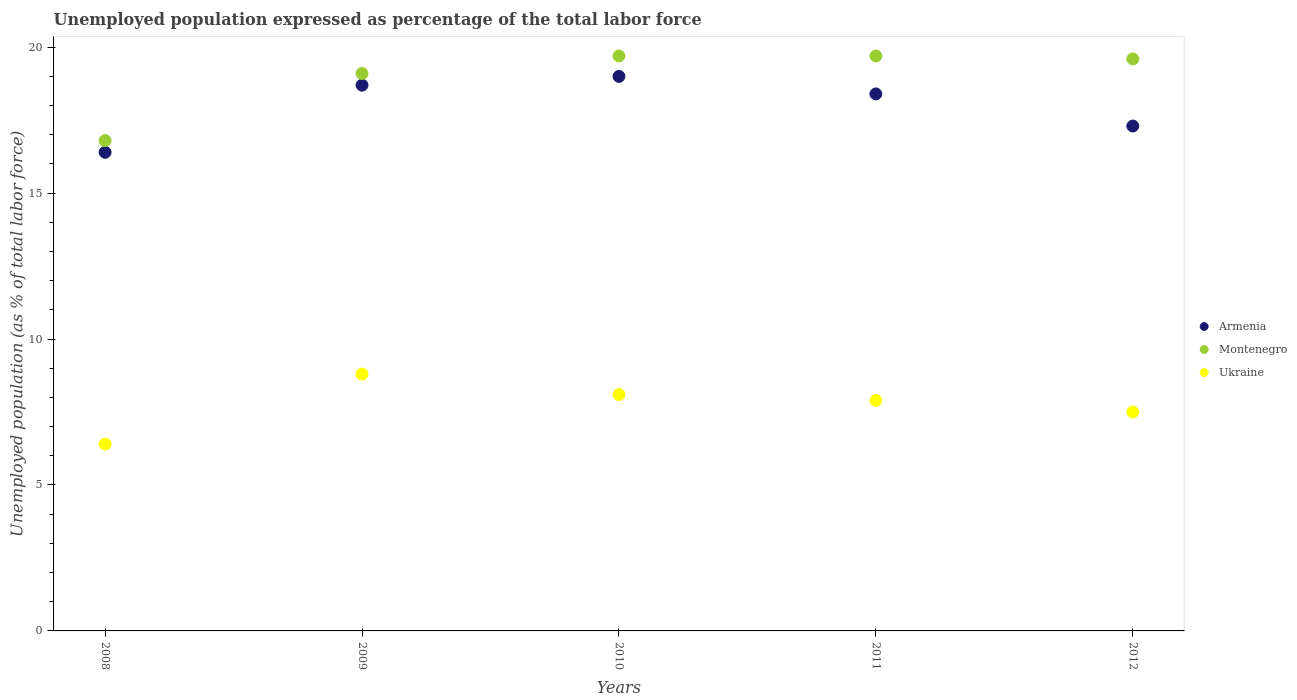Is the number of dotlines equal to the number of legend labels?
Give a very brief answer. Yes. What is the unemployment in in Montenegro in 2010?
Give a very brief answer. 19.7. Across all years, what is the minimum unemployment in in Armenia?
Ensure brevity in your answer.  16.4. What is the total unemployment in in Ukraine in the graph?
Keep it short and to the point. 38.7. What is the difference between the unemployment in in Ukraine in 2009 and that in 2011?
Make the answer very short. 0.9. What is the difference between the unemployment in in Ukraine in 2011 and the unemployment in in Armenia in 2012?
Offer a very short reply. -9.4. What is the average unemployment in in Ukraine per year?
Your answer should be compact. 7.74. In the year 2011, what is the difference between the unemployment in in Armenia and unemployment in in Montenegro?
Ensure brevity in your answer.  -1.3. What is the ratio of the unemployment in in Armenia in 2011 to that in 2012?
Your answer should be compact. 1.06. What is the difference between the highest and the second highest unemployment in in Montenegro?
Offer a very short reply. 0. What is the difference between the highest and the lowest unemployment in in Armenia?
Your answer should be compact. 2.6. Is the sum of the unemployment in in Montenegro in 2009 and 2011 greater than the maximum unemployment in in Armenia across all years?
Keep it short and to the point. Yes. Is it the case that in every year, the sum of the unemployment in in Ukraine and unemployment in in Armenia  is greater than the unemployment in in Montenegro?
Your response must be concise. Yes. Is the unemployment in in Montenegro strictly greater than the unemployment in in Ukraine over the years?
Provide a short and direct response. Yes. Is the unemployment in in Armenia strictly less than the unemployment in in Montenegro over the years?
Your answer should be compact. Yes. How many dotlines are there?
Give a very brief answer. 3. How many years are there in the graph?
Your response must be concise. 5. How are the legend labels stacked?
Your response must be concise. Vertical. What is the title of the graph?
Keep it short and to the point. Unemployed population expressed as percentage of the total labor force. What is the label or title of the Y-axis?
Ensure brevity in your answer.  Unemployed population (as % of total labor force). What is the Unemployed population (as % of total labor force) in Armenia in 2008?
Give a very brief answer. 16.4. What is the Unemployed population (as % of total labor force) in Montenegro in 2008?
Make the answer very short. 16.8. What is the Unemployed population (as % of total labor force) in Ukraine in 2008?
Keep it short and to the point. 6.4. What is the Unemployed population (as % of total labor force) in Armenia in 2009?
Your answer should be very brief. 18.7. What is the Unemployed population (as % of total labor force) in Montenegro in 2009?
Your answer should be very brief. 19.1. What is the Unemployed population (as % of total labor force) in Ukraine in 2009?
Provide a succinct answer. 8.8. What is the Unemployed population (as % of total labor force) in Montenegro in 2010?
Provide a succinct answer. 19.7. What is the Unemployed population (as % of total labor force) in Ukraine in 2010?
Ensure brevity in your answer.  8.1. What is the Unemployed population (as % of total labor force) of Armenia in 2011?
Give a very brief answer. 18.4. What is the Unemployed population (as % of total labor force) of Montenegro in 2011?
Offer a very short reply. 19.7. What is the Unemployed population (as % of total labor force) of Ukraine in 2011?
Your answer should be compact. 7.9. What is the Unemployed population (as % of total labor force) of Armenia in 2012?
Provide a short and direct response. 17.3. What is the Unemployed population (as % of total labor force) in Montenegro in 2012?
Give a very brief answer. 19.6. Across all years, what is the maximum Unemployed population (as % of total labor force) in Montenegro?
Provide a short and direct response. 19.7. Across all years, what is the maximum Unemployed population (as % of total labor force) in Ukraine?
Your answer should be compact. 8.8. Across all years, what is the minimum Unemployed population (as % of total labor force) in Armenia?
Offer a very short reply. 16.4. Across all years, what is the minimum Unemployed population (as % of total labor force) of Montenegro?
Provide a succinct answer. 16.8. Across all years, what is the minimum Unemployed population (as % of total labor force) of Ukraine?
Ensure brevity in your answer.  6.4. What is the total Unemployed population (as % of total labor force) in Armenia in the graph?
Make the answer very short. 89.8. What is the total Unemployed population (as % of total labor force) in Montenegro in the graph?
Make the answer very short. 94.9. What is the total Unemployed population (as % of total labor force) of Ukraine in the graph?
Your answer should be compact. 38.7. What is the difference between the Unemployed population (as % of total labor force) in Armenia in 2008 and that in 2009?
Give a very brief answer. -2.3. What is the difference between the Unemployed population (as % of total labor force) in Ukraine in 2008 and that in 2009?
Your answer should be very brief. -2.4. What is the difference between the Unemployed population (as % of total labor force) of Armenia in 2008 and that in 2010?
Ensure brevity in your answer.  -2.6. What is the difference between the Unemployed population (as % of total labor force) in Montenegro in 2008 and that in 2010?
Provide a succinct answer. -2.9. What is the difference between the Unemployed population (as % of total labor force) in Ukraine in 2008 and that in 2010?
Provide a short and direct response. -1.7. What is the difference between the Unemployed population (as % of total labor force) of Ukraine in 2008 and that in 2011?
Give a very brief answer. -1.5. What is the difference between the Unemployed population (as % of total labor force) in Ukraine in 2008 and that in 2012?
Your response must be concise. -1.1. What is the difference between the Unemployed population (as % of total labor force) of Armenia in 2009 and that in 2010?
Provide a succinct answer. -0.3. What is the difference between the Unemployed population (as % of total labor force) of Montenegro in 2009 and that in 2010?
Provide a succinct answer. -0.6. What is the difference between the Unemployed population (as % of total labor force) in Armenia in 2009 and that in 2011?
Keep it short and to the point. 0.3. What is the difference between the Unemployed population (as % of total labor force) of Ukraine in 2009 and that in 2011?
Your answer should be compact. 0.9. What is the difference between the Unemployed population (as % of total labor force) in Armenia in 2009 and that in 2012?
Provide a succinct answer. 1.4. What is the difference between the Unemployed population (as % of total labor force) of Montenegro in 2009 and that in 2012?
Provide a short and direct response. -0.5. What is the difference between the Unemployed population (as % of total labor force) in Armenia in 2010 and that in 2011?
Your answer should be compact. 0.6. What is the difference between the Unemployed population (as % of total labor force) in Montenegro in 2010 and that in 2011?
Offer a terse response. 0. What is the difference between the Unemployed population (as % of total labor force) of Ukraine in 2010 and that in 2011?
Make the answer very short. 0.2. What is the difference between the Unemployed population (as % of total labor force) in Montenegro in 2010 and that in 2012?
Your response must be concise. 0.1. What is the difference between the Unemployed population (as % of total labor force) in Montenegro in 2008 and the Unemployed population (as % of total labor force) in Ukraine in 2009?
Give a very brief answer. 8. What is the difference between the Unemployed population (as % of total labor force) of Armenia in 2008 and the Unemployed population (as % of total labor force) of Montenegro in 2010?
Offer a very short reply. -3.3. What is the difference between the Unemployed population (as % of total labor force) in Montenegro in 2008 and the Unemployed population (as % of total labor force) in Ukraine in 2010?
Provide a short and direct response. 8.7. What is the difference between the Unemployed population (as % of total labor force) in Montenegro in 2008 and the Unemployed population (as % of total labor force) in Ukraine in 2011?
Provide a succinct answer. 8.9. What is the difference between the Unemployed population (as % of total labor force) in Armenia in 2008 and the Unemployed population (as % of total labor force) in Montenegro in 2012?
Your response must be concise. -3.2. What is the difference between the Unemployed population (as % of total labor force) of Montenegro in 2008 and the Unemployed population (as % of total labor force) of Ukraine in 2012?
Make the answer very short. 9.3. What is the difference between the Unemployed population (as % of total labor force) in Armenia in 2009 and the Unemployed population (as % of total labor force) in Montenegro in 2010?
Make the answer very short. -1. What is the difference between the Unemployed population (as % of total labor force) in Armenia in 2009 and the Unemployed population (as % of total labor force) in Ukraine in 2010?
Ensure brevity in your answer.  10.6. What is the difference between the Unemployed population (as % of total labor force) in Montenegro in 2009 and the Unemployed population (as % of total labor force) in Ukraine in 2010?
Make the answer very short. 11. What is the difference between the Unemployed population (as % of total labor force) in Armenia in 2009 and the Unemployed population (as % of total labor force) in Montenegro in 2011?
Keep it short and to the point. -1. What is the difference between the Unemployed population (as % of total labor force) in Armenia in 2009 and the Unemployed population (as % of total labor force) in Ukraine in 2011?
Provide a short and direct response. 10.8. What is the difference between the Unemployed population (as % of total labor force) in Montenegro in 2009 and the Unemployed population (as % of total labor force) in Ukraine in 2011?
Offer a terse response. 11.2. What is the difference between the Unemployed population (as % of total labor force) in Armenia in 2009 and the Unemployed population (as % of total labor force) in Montenegro in 2012?
Provide a succinct answer. -0.9. What is the difference between the Unemployed population (as % of total labor force) in Armenia in 2009 and the Unemployed population (as % of total labor force) in Ukraine in 2012?
Offer a very short reply. 11.2. What is the difference between the Unemployed population (as % of total labor force) in Montenegro in 2009 and the Unemployed population (as % of total labor force) in Ukraine in 2012?
Provide a succinct answer. 11.6. What is the difference between the Unemployed population (as % of total labor force) in Armenia in 2010 and the Unemployed population (as % of total labor force) in Montenegro in 2011?
Provide a short and direct response. -0.7. What is the difference between the Unemployed population (as % of total labor force) in Montenegro in 2010 and the Unemployed population (as % of total labor force) in Ukraine in 2011?
Give a very brief answer. 11.8. What is the difference between the Unemployed population (as % of total labor force) of Armenia in 2010 and the Unemployed population (as % of total labor force) of Ukraine in 2012?
Provide a short and direct response. 11.5. What is the difference between the Unemployed population (as % of total labor force) of Montenegro in 2010 and the Unemployed population (as % of total labor force) of Ukraine in 2012?
Ensure brevity in your answer.  12.2. What is the difference between the Unemployed population (as % of total labor force) of Armenia in 2011 and the Unemployed population (as % of total labor force) of Ukraine in 2012?
Offer a terse response. 10.9. What is the difference between the Unemployed population (as % of total labor force) of Montenegro in 2011 and the Unemployed population (as % of total labor force) of Ukraine in 2012?
Ensure brevity in your answer.  12.2. What is the average Unemployed population (as % of total labor force) in Armenia per year?
Make the answer very short. 17.96. What is the average Unemployed population (as % of total labor force) of Montenegro per year?
Provide a succinct answer. 18.98. What is the average Unemployed population (as % of total labor force) of Ukraine per year?
Ensure brevity in your answer.  7.74. In the year 2008, what is the difference between the Unemployed population (as % of total labor force) of Armenia and Unemployed population (as % of total labor force) of Montenegro?
Offer a very short reply. -0.4. In the year 2008, what is the difference between the Unemployed population (as % of total labor force) in Armenia and Unemployed population (as % of total labor force) in Ukraine?
Provide a short and direct response. 10. In the year 2008, what is the difference between the Unemployed population (as % of total labor force) of Montenegro and Unemployed population (as % of total labor force) of Ukraine?
Give a very brief answer. 10.4. In the year 2009, what is the difference between the Unemployed population (as % of total labor force) of Armenia and Unemployed population (as % of total labor force) of Montenegro?
Provide a succinct answer. -0.4. In the year 2011, what is the difference between the Unemployed population (as % of total labor force) of Armenia and Unemployed population (as % of total labor force) of Montenegro?
Keep it short and to the point. -1.3. In the year 2011, what is the difference between the Unemployed population (as % of total labor force) in Armenia and Unemployed population (as % of total labor force) in Ukraine?
Your response must be concise. 10.5. In the year 2012, what is the difference between the Unemployed population (as % of total labor force) of Montenegro and Unemployed population (as % of total labor force) of Ukraine?
Your answer should be very brief. 12.1. What is the ratio of the Unemployed population (as % of total labor force) in Armenia in 2008 to that in 2009?
Offer a terse response. 0.88. What is the ratio of the Unemployed population (as % of total labor force) of Montenegro in 2008 to that in 2009?
Make the answer very short. 0.88. What is the ratio of the Unemployed population (as % of total labor force) of Ukraine in 2008 to that in 2009?
Ensure brevity in your answer.  0.73. What is the ratio of the Unemployed population (as % of total labor force) in Armenia in 2008 to that in 2010?
Ensure brevity in your answer.  0.86. What is the ratio of the Unemployed population (as % of total labor force) in Montenegro in 2008 to that in 2010?
Offer a very short reply. 0.85. What is the ratio of the Unemployed population (as % of total labor force) in Ukraine in 2008 to that in 2010?
Give a very brief answer. 0.79. What is the ratio of the Unemployed population (as % of total labor force) of Armenia in 2008 to that in 2011?
Make the answer very short. 0.89. What is the ratio of the Unemployed population (as % of total labor force) of Montenegro in 2008 to that in 2011?
Provide a succinct answer. 0.85. What is the ratio of the Unemployed population (as % of total labor force) in Ukraine in 2008 to that in 2011?
Ensure brevity in your answer.  0.81. What is the ratio of the Unemployed population (as % of total labor force) in Armenia in 2008 to that in 2012?
Provide a short and direct response. 0.95. What is the ratio of the Unemployed population (as % of total labor force) in Montenegro in 2008 to that in 2012?
Provide a short and direct response. 0.86. What is the ratio of the Unemployed population (as % of total labor force) of Ukraine in 2008 to that in 2012?
Your answer should be compact. 0.85. What is the ratio of the Unemployed population (as % of total labor force) of Armenia in 2009 to that in 2010?
Offer a very short reply. 0.98. What is the ratio of the Unemployed population (as % of total labor force) in Montenegro in 2009 to that in 2010?
Make the answer very short. 0.97. What is the ratio of the Unemployed population (as % of total labor force) in Ukraine in 2009 to that in 2010?
Your response must be concise. 1.09. What is the ratio of the Unemployed population (as % of total labor force) in Armenia in 2009 to that in 2011?
Provide a succinct answer. 1.02. What is the ratio of the Unemployed population (as % of total labor force) of Montenegro in 2009 to that in 2011?
Offer a very short reply. 0.97. What is the ratio of the Unemployed population (as % of total labor force) in Ukraine in 2009 to that in 2011?
Offer a very short reply. 1.11. What is the ratio of the Unemployed population (as % of total labor force) of Armenia in 2009 to that in 2012?
Make the answer very short. 1.08. What is the ratio of the Unemployed population (as % of total labor force) in Montenegro in 2009 to that in 2012?
Keep it short and to the point. 0.97. What is the ratio of the Unemployed population (as % of total labor force) of Ukraine in 2009 to that in 2012?
Keep it short and to the point. 1.17. What is the ratio of the Unemployed population (as % of total labor force) of Armenia in 2010 to that in 2011?
Keep it short and to the point. 1.03. What is the ratio of the Unemployed population (as % of total labor force) of Ukraine in 2010 to that in 2011?
Your response must be concise. 1.03. What is the ratio of the Unemployed population (as % of total labor force) of Armenia in 2010 to that in 2012?
Ensure brevity in your answer.  1.1. What is the ratio of the Unemployed population (as % of total labor force) in Montenegro in 2010 to that in 2012?
Provide a succinct answer. 1.01. What is the ratio of the Unemployed population (as % of total labor force) in Armenia in 2011 to that in 2012?
Your answer should be compact. 1.06. What is the ratio of the Unemployed population (as % of total labor force) in Ukraine in 2011 to that in 2012?
Offer a very short reply. 1.05. What is the difference between the highest and the second highest Unemployed population (as % of total labor force) of Armenia?
Your answer should be compact. 0.3. What is the difference between the highest and the second highest Unemployed population (as % of total labor force) of Ukraine?
Provide a succinct answer. 0.7. What is the difference between the highest and the lowest Unemployed population (as % of total labor force) of Montenegro?
Provide a succinct answer. 2.9. What is the difference between the highest and the lowest Unemployed population (as % of total labor force) in Ukraine?
Provide a short and direct response. 2.4. 